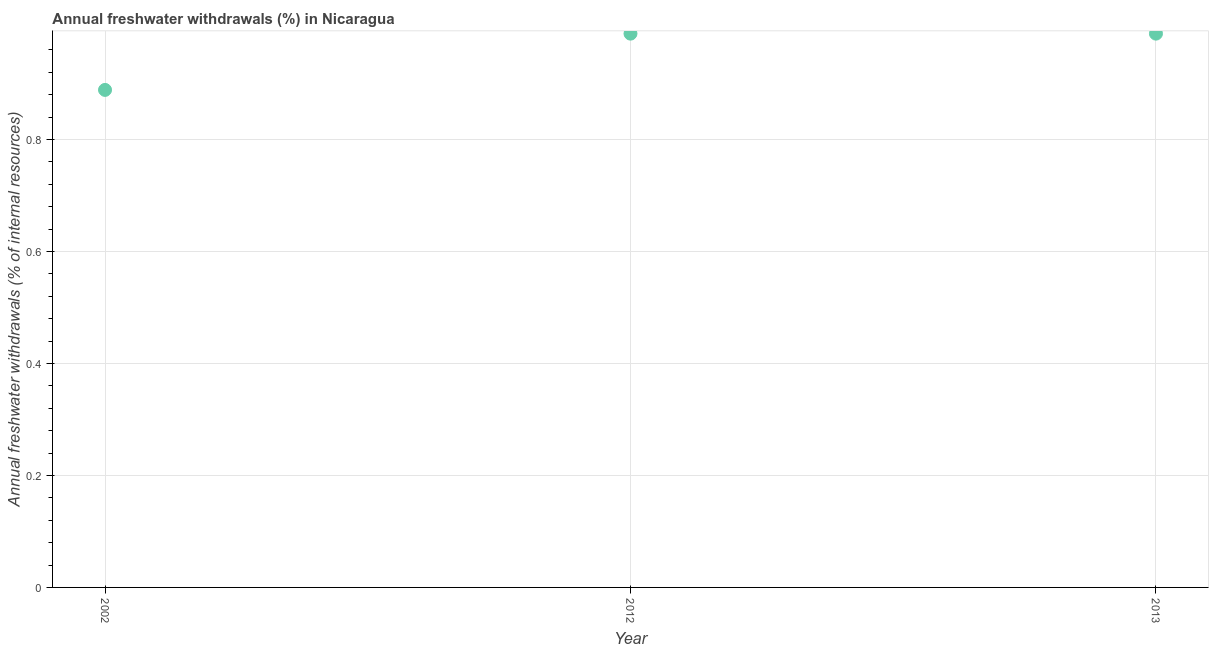What is the annual freshwater withdrawals in 2013?
Provide a short and direct response. 0.99. Across all years, what is the maximum annual freshwater withdrawals?
Provide a short and direct response. 0.99. Across all years, what is the minimum annual freshwater withdrawals?
Offer a very short reply. 0.89. What is the sum of the annual freshwater withdrawals?
Offer a terse response. 2.87. What is the average annual freshwater withdrawals per year?
Offer a very short reply. 0.96. What is the median annual freshwater withdrawals?
Your answer should be compact. 0.99. In how many years, is the annual freshwater withdrawals greater than 0.68 %?
Make the answer very short. 3. Do a majority of the years between 2002 and 2012 (inclusive) have annual freshwater withdrawals greater than 0.16 %?
Your answer should be very brief. Yes. What is the ratio of the annual freshwater withdrawals in 2002 to that in 2013?
Your response must be concise. 0.9. Is the difference between the annual freshwater withdrawals in 2012 and 2013 greater than the difference between any two years?
Ensure brevity in your answer.  No. Is the sum of the annual freshwater withdrawals in 2002 and 2012 greater than the maximum annual freshwater withdrawals across all years?
Offer a terse response. Yes. What is the difference between the highest and the lowest annual freshwater withdrawals?
Provide a succinct answer. 0.1. In how many years, is the annual freshwater withdrawals greater than the average annual freshwater withdrawals taken over all years?
Provide a short and direct response. 2. How many dotlines are there?
Give a very brief answer. 1. How many years are there in the graph?
Your answer should be compact. 3. What is the title of the graph?
Your answer should be compact. Annual freshwater withdrawals (%) in Nicaragua. What is the label or title of the X-axis?
Your answer should be very brief. Year. What is the label or title of the Y-axis?
Your answer should be very brief. Annual freshwater withdrawals (% of internal resources). What is the Annual freshwater withdrawals (% of internal resources) in 2002?
Make the answer very short. 0.89. What is the Annual freshwater withdrawals (% of internal resources) in 2012?
Give a very brief answer. 0.99. What is the Annual freshwater withdrawals (% of internal resources) in 2013?
Provide a short and direct response. 0.99. What is the difference between the Annual freshwater withdrawals (% of internal resources) in 2002 and 2012?
Keep it short and to the point. -0.1. What is the difference between the Annual freshwater withdrawals (% of internal resources) in 2002 and 2013?
Your response must be concise. -0.1. What is the difference between the Annual freshwater withdrawals (% of internal resources) in 2012 and 2013?
Keep it short and to the point. 0. What is the ratio of the Annual freshwater withdrawals (% of internal resources) in 2002 to that in 2012?
Give a very brief answer. 0.9. What is the ratio of the Annual freshwater withdrawals (% of internal resources) in 2002 to that in 2013?
Keep it short and to the point. 0.9. 